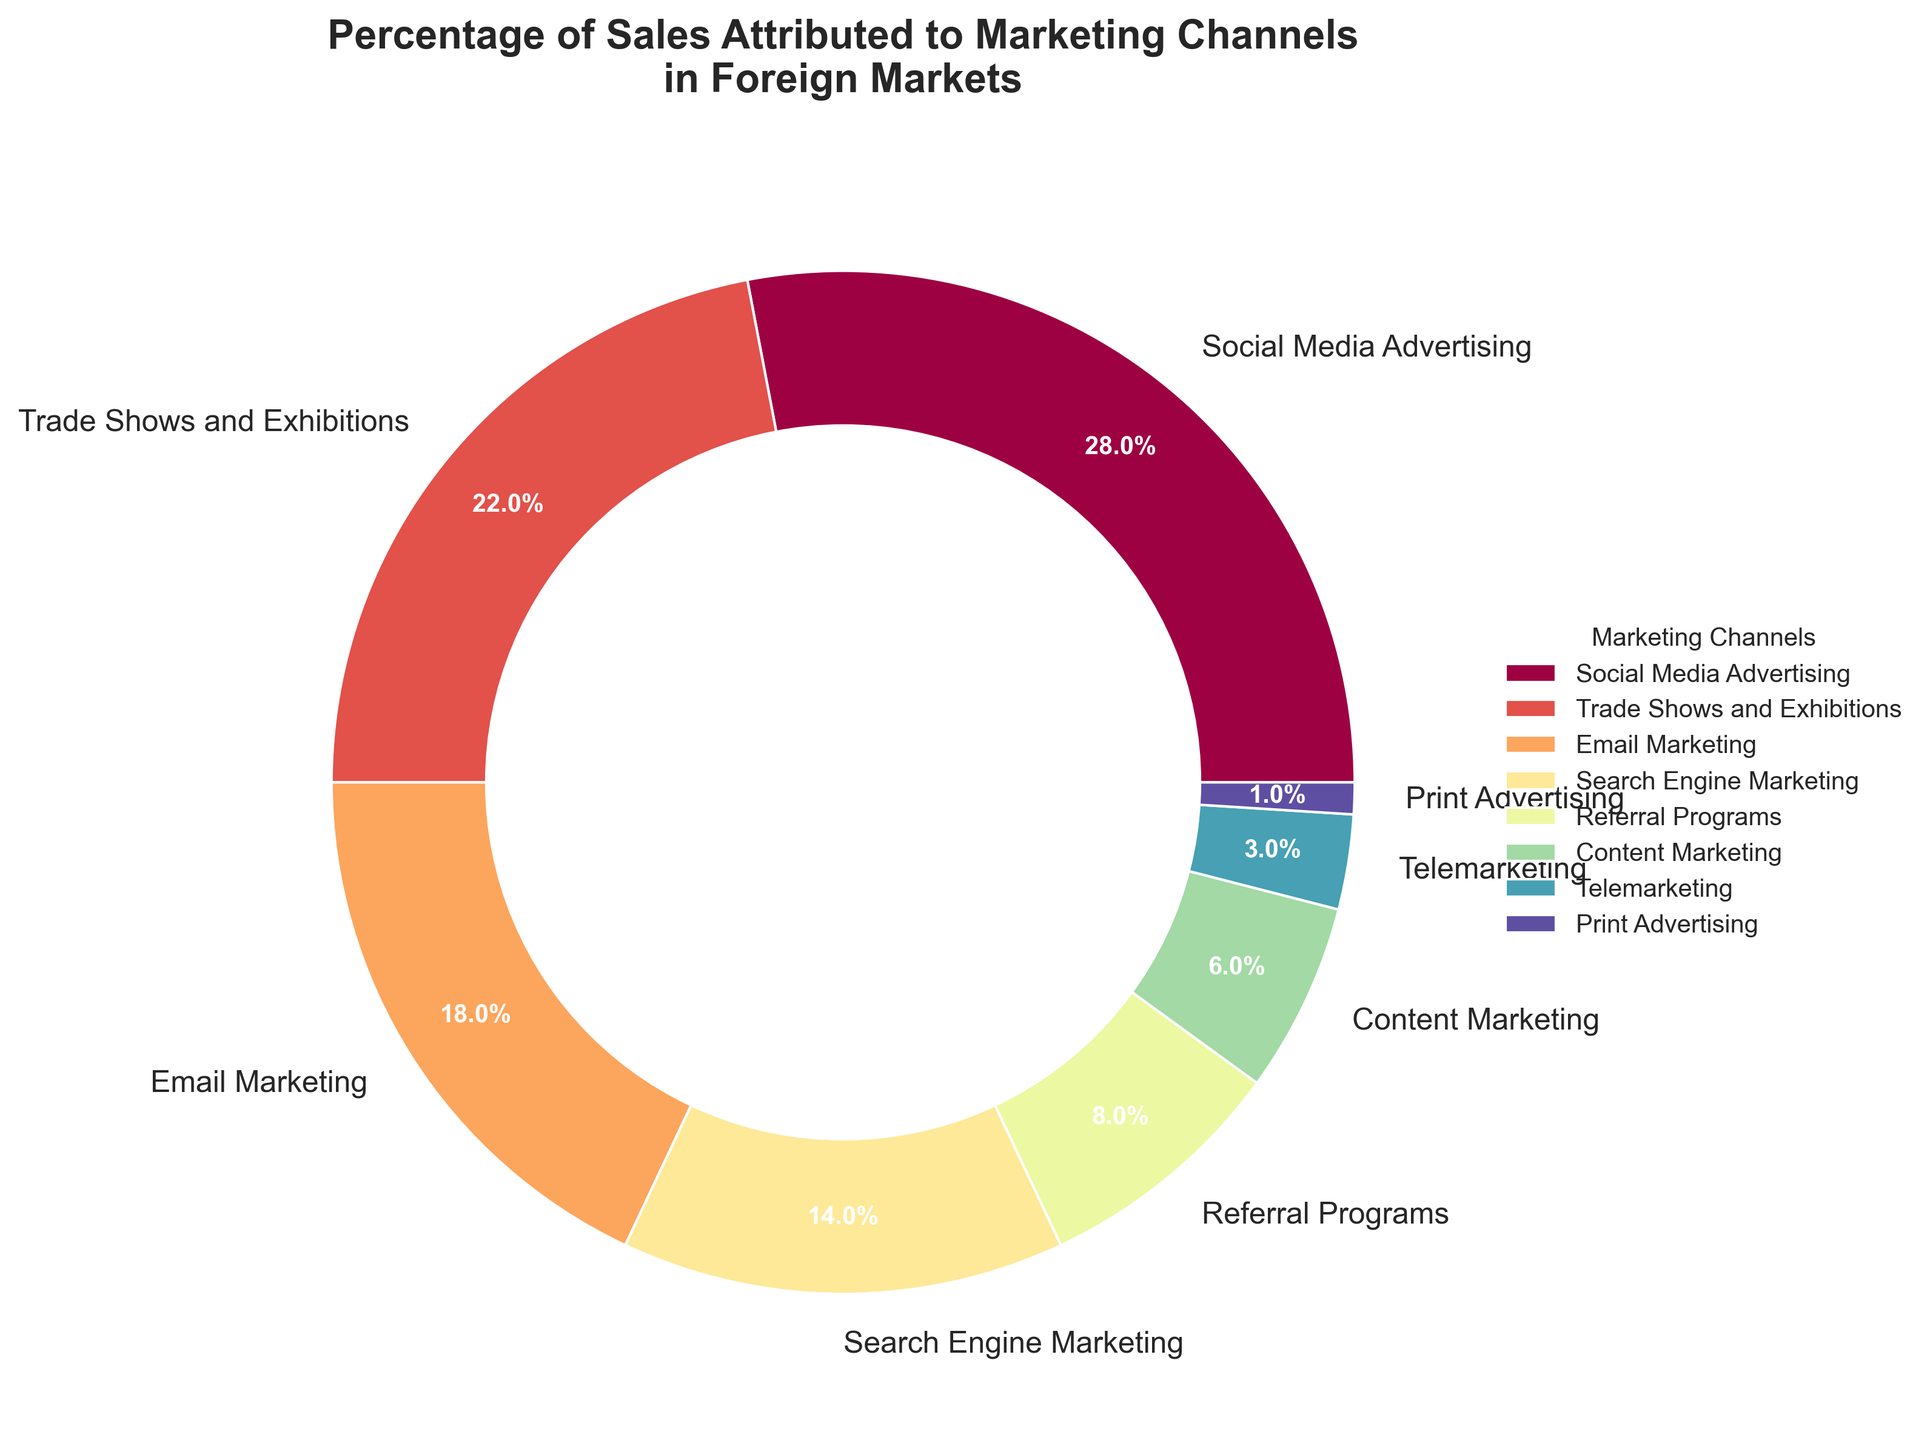What marketing channel has the highest percentage of sales? The largest segment in the pie chart represents the marketing channel with the highest percentage. The label associated with this segment indicates it is Social Media Advertising at 28%.
Answer: Social Media Advertising What two channels combined contribute to 40% of sales? To find the channels, sum their percentages: Social Media Advertising (28%) + Trade Shows and Exhibitions (22%) = 50%. Then check the next largest combination: Trade Shows and Exhibitions (22%) + Email Marketing (18%) = 40%.
Answer: Trade Shows and Exhibitions, Email Marketing Which marketing channel contributes the least to sales? The smallest segment in the pie chart represents the channel with the least percentage. The label associated with this segment indicates it is Print Advertising at 1%.
Answer: Print Advertising How much more does Social Media Advertising contribute compared to Telemarketing? Subtract the percentage of Telemarketing from Social Media Advertising: 28% - 3% = 25%.
Answer: 25% If we sum up the percentages of Referral Programs and Content Marketing, what do we get? Add the percentages of Referral Programs (8%) and Content Marketing (6%): 8% + 6% = 14%.
Answer: 14% What is the combined percentage of sales attributed to digital marketing channels (Social Media Advertising, Email Marketing, Search Engine Marketing, Content Marketing)? Sum the percentages of these channels: 28% (Social Media Advertising) + 18% (Email Marketing) + 14% (Search Engine Marketing) + 6% (Content Marketing) = 66%.
Answer: 66% Which channel has a percentage closest to 10%? Check the percentages and identify the closest to 10%. Referral Programs at 8% is the nearest.
Answer: Referral Programs Are there more channels contributing less than or equal to 10% or more than 10%? Count the channels: less than or equal to 10%: (Referral Programs 8%, Content Marketing 6%, Telemarketing 3%, Print Advertising 1%) = 4; more than 10%: (Social Media Advertising 28%, Trade Shows and Exhibitions 22%, Email Marketing 18%, Search Engine Marketing 14%) = 4.
Answer: Equal By how much does Email Marketing exceed Search Engine Marketing in its contribution to sales? Subtract the percentage of Search Engine Marketing from Email Marketing: 18% - 14% = 4%.
Answer: 4% What percentage do non-digital marketing channels (Trade Shows and Exhibitions, Telemarketing, Print Advertising) contribute in total? Sum their percentages: Trade Shows and Exhibitions (22%) + Telemarketing (3%) + Print Advertising (1%) = 26%.
Answer: 26% 